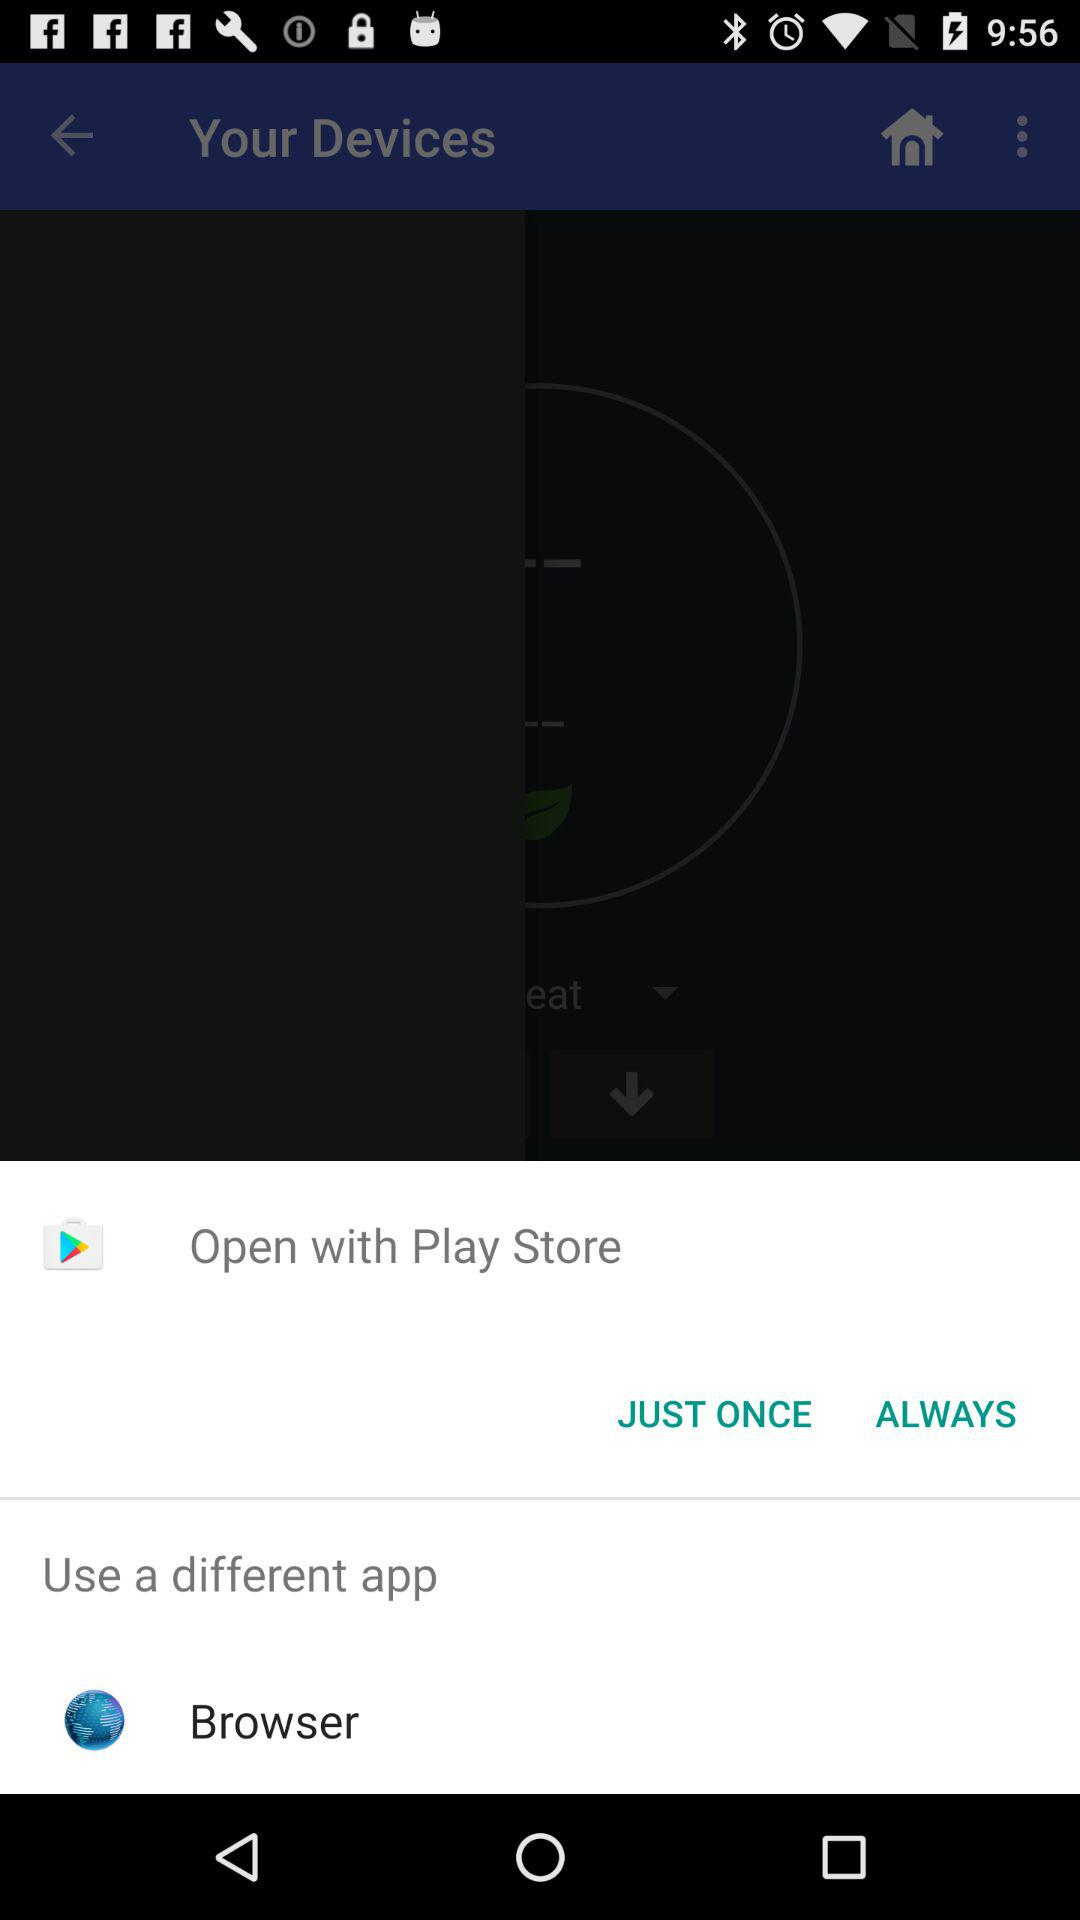What are the available options to open? The available options are "Play Store" and "Browser". 